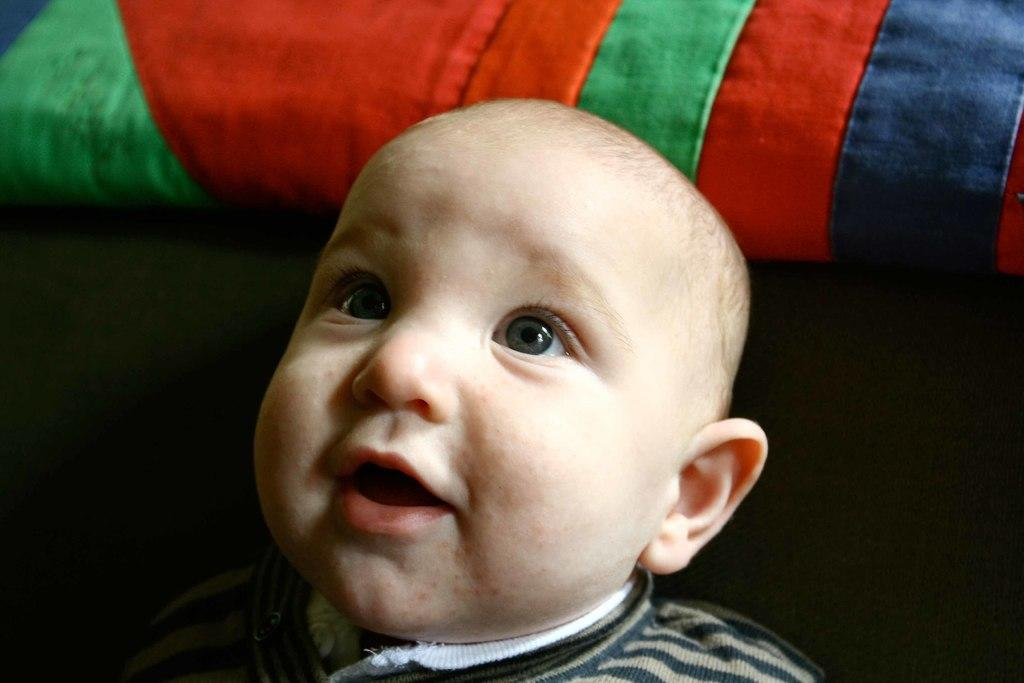What is the main subject of the image? There is a baby boy in the image. What is the baby boy doing in the image? The baby boy is smiling. What object can be seen at the top of the image? There is a pillow at the top of the image. What month is the baby boy celebrating in the image? There is no indication of a specific month or celebration in the image. What type of paint is used on the pillow in the image? There is no paint visible on the pillow in the image. 